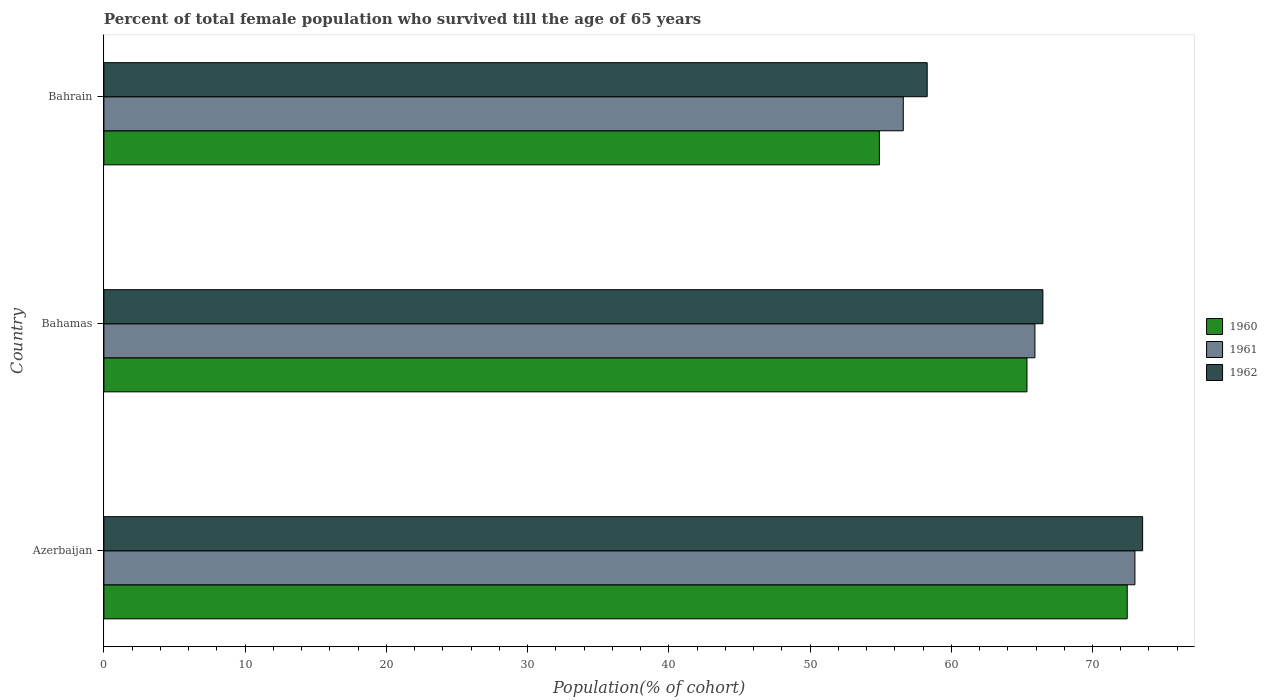How many different coloured bars are there?
Provide a succinct answer. 3. How many groups of bars are there?
Provide a short and direct response. 3. Are the number of bars on each tick of the Y-axis equal?
Give a very brief answer. Yes. How many bars are there on the 3rd tick from the top?
Offer a terse response. 3. What is the label of the 1st group of bars from the top?
Provide a short and direct response. Bahrain. In how many cases, is the number of bars for a given country not equal to the number of legend labels?
Offer a very short reply. 0. What is the percentage of total female population who survived till the age of 65 years in 1960 in Bahamas?
Your answer should be very brief. 65.36. Across all countries, what is the maximum percentage of total female population who survived till the age of 65 years in 1960?
Keep it short and to the point. 72.46. Across all countries, what is the minimum percentage of total female population who survived till the age of 65 years in 1961?
Ensure brevity in your answer.  56.6. In which country was the percentage of total female population who survived till the age of 65 years in 1962 maximum?
Offer a terse response. Azerbaijan. In which country was the percentage of total female population who survived till the age of 65 years in 1962 minimum?
Your answer should be very brief. Bahrain. What is the total percentage of total female population who survived till the age of 65 years in 1960 in the graph?
Provide a short and direct response. 192.73. What is the difference between the percentage of total female population who survived till the age of 65 years in 1960 in Bahamas and that in Bahrain?
Your answer should be compact. 10.45. What is the difference between the percentage of total female population who survived till the age of 65 years in 1962 in Bahrain and the percentage of total female population who survived till the age of 65 years in 1960 in Azerbaijan?
Ensure brevity in your answer.  -14.16. What is the average percentage of total female population who survived till the age of 65 years in 1961 per country?
Keep it short and to the point. 65.18. What is the difference between the percentage of total female population who survived till the age of 65 years in 1960 and percentage of total female population who survived till the age of 65 years in 1961 in Bahrain?
Ensure brevity in your answer.  -1.69. In how many countries, is the percentage of total female population who survived till the age of 65 years in 1961 greater than 34 %?
Keep it short and to the point. 3. What is the ratio of the percentage of total female population who survived till the age of 65 years in 1962 in Azerbaijan to that in Bahamas?
Offer a terse response. 1.11. Is the percentage of total female population who survived till the age of 65 years in 1962 in Bahamas less than that in Bahrain?
Provide a short and direct response. No. What is the difference between the highest and the second highest percentage of total female population who survived till the age of 65 years in 1962?
Ensure brevity in your answer.  7.06. What is the difference between the highest and the lowest percentage of total female population who survived till the age of 65 years in 1962?
Your answer should be very brief. 15.25. Is the sum of the percentage of total female population who survived till the age of 65 years in 1962 in Azerbaijan and Bahamas greater than the maximum percentage of total female population who survived till the age of 65 years in 1960 across all countries?
Offer a very short reply. Yes. What does the 3rd bar from the top in Azerbaijan represents?
Make the answer very short. 1960. How many countries are there in the graph?
Offer a terse response. 3. Are the values on the major ticks of X-axis written in scientific E-notation?
Offer a terse response. No. Does the graph contain any zero values?
Make the answer very short. No. Where does the legend appear in the graph?
Your answer should be very brief. Center right. How many legend labels are there?
Ensure brevity in your answer.  3. How are the legend labels stacked?
Give a very brief answer. Vertical. What is the title of the graph?
Make the answer very short. Percent of total female population who survived till the age of 65 years. What is the label or title of the X-axis?
Your answer should be compact. Population(% of cohort). What is the Population(% of cohort) of 1960 in Azerbaijan?
Give a very brief answer. 72.46. What is the Population(% of cohort) in 1961 in Azerbaijan?
Your answer should be compact. 73. What is the Population(% of cohort) of 1962 in Azerbaijan?
Your answer should be very brief. 73.55. What is the Population(% of cohort) in 1960 in Bahamas?
Your answer should be very brief. 65.36. What is the Population(% of cohort) of 1961 in Bahamas?
Offer a very short reply. 65.92. What is the Population(% of cohort) in 1962 in Bahamas?
Your response must be concise. 66.49. What is the Population(% of cohort) in 1960 in Bahrain?
Make the answer very short. 54.91. What is the Population(% of cohort) of 1961 in Bahrain?
Provide a short and direct response. 56.6. What is the Population(% of cohort) of 1962 in Bahrain?
Offer a very short reply. 58.3. Across all countries, what is the maximum Population(% of cohort) in 1960?
Make the answer very short. 72.46. Across all countries, what is the maximum Population(% of cohort) in 1961?
Provide a short and direct response. 73. Across all countries, what is the maximum Population(% of cohort) of 1962?
Ensure brevity in your answer.  73.55. Across all countries, what is the minimum Population(% of cohort) in 1960?
Your response must be concise. 54.91. Across all countries, what is the minimum Population(% of cohort) in 1961?
Offer a very short reply. 56.6. Across all countries, what is the minimum Population(% of cohort) of 1962?
Your answer should be very brief. 58.3. What is the total Population(% of cohort) in 1960 in the graph?
Offer a terse response. 192.73. What is the total Population(% of cohort) in 1961 in the graph?
Provide a succinct answer. 195.53. What is the total Population(% of cohort) in 1962 in the graph?
Ensure brevity in your answer.  198.33. What is the difference between the Population(% of cohort) in 1960 in Azerbaijan and that in Bahamas?
Offer a very short reply. 7.1. What is the difference between the Population(% of cohort) in 1961 in Azerbaijan and that in Bahamas?
Provide a short and direct response. 7.08. What is the difference between the Population(% of cohort) in 1962 in Azerbaijan and that in Bahamas?
Ensure brevity in your answer.  7.06. What is the difference between the Population(% of cohort) of 1960 in Azerbaijan and that in Bahrain?
Provide a short and direct response. 17.55. What is the difference between the Population(% of cohort) of 1961 in Azerbaijan and that in Bahrain?
Your answer should be very brief. 16.4. What is the difference between the Population(% of cohort) of 1962 in Azerbaijan and that in Bahrain?
Ensure brevity in your answer.  15.25. What is the difference between the Population(% of cohort) of 1960 in Bahamas and that in Bahrain?
Your response must be concise. 10.45. What is the difference between the Population(% of cohort) in 1961 in Bahamas and that in Bahrain?
Offer a very short reply. 9.32. What is the difference between the Population(% of cohort) of 1962 in Bahamas and that in Bahrain?
Give a very brief answer. 8.19. What is the difference between the Population(% of cohort) in 1960 in Azerbaijan and the Population(% of cohort) in 1961 in Bahamas?
Provide a short and direct response. 6.54. What is the difference between the Population(% of cohort) in 1960 in Azerbaijan and the Population(% of cohort) in 1962 in Bahamas?
Provide a succinct answer. 5.97. What is the difference between the Population(% of cohort) in 1961 in Azerbaijan and the Population(% of cohort) in 1962 in Bahamas?
Make the answer very short. 6.52. What is the difference between the Population(% of cohort) in 1960 in Azerbaijan and the Population(% of cohort) in 1961 in Bahrain?
Offer a terse response. 15.86. What is the difference between the Population(% of cohort) of 1960 in Azerbaijan and the Population(% of cohort) of 1962 in Bahrain?
Provide a short and direct response. 14.16. What is the difference between the Population(% of cohort) of 1961 in Azerbaijan and the Population(% of cohort) of 1962 in Bahrain?
Keep it short and to the point. 14.71. What is the difference between the Population(% of cohort) in 1960 in Bahamas and the Population(% of cohort) in 1961 in Bahrain?
Provide a succinct answer. 8.76. What is the difference between the Population(% of cohort) in 1960 in Bahamas and the Population(% of cohort) in 1962 in Bahrain?
Keep it short and to the point. 7.07. What is the difference between the Population(% of cohort) in 1961 in Bahamas and the Population(% of cohort) in 1962 in Bahrain?
Provide a succinct answer. 7.63. What is the average Population(% of cohort) of 1960 per country?
Provide a succinct answer. 64.24. What is the average Population(% of cohort) of 1961 per country?
Give a very brief answer. 65.18. What is the average Population(% of cohort) of 1962 per country?
Your response must be concise. 66.11. What is the difference between the Population(% of cohort) of 1960 and Population(% of cohort) of 1961 in Azerbaijan?
Provide a succinct answer. -0.55. What is the difference between the Population(% of cohort) of 1960 and Population(% of cohort) of 1962 in Azerbaijan?
Offer a terse response. -1.09. What is the difference between the Population(% of cohort) in 1961 and Population(% of cohort) in 1962 in Azerbaijan?
Your answer should be compact. -0.55. What is the difference between the Population(% of cohort) of 1960 and Population(% of cohort) of 1961 in Bahamas?
Offer a terse response. -0.56. What is the difference between the Population(% of cohort) of 1960 and Population(% of cohort) of 1962 in Bahamas?
Give a very brief answer. -1.13. What is the difference between the Population(% of cohort) of 1961 and Population(% of cohort) of 1962 in Bahamas?
Offer a terse response. -0.56. What is the difference between the Population(% of cohort) of 1960 and Population(% of cohort) of 1961 in Bahrain?
Your answer should be very brief. -1.69. What is the difference between the Population(% of cohort) of 1960 and Population(% of cohort) of 1962 in Bahrain?
Your answer should be compact. -3.38. What is the difference between the Population(% of cohort) of 1961 and Population(% of cohort) of 1962 in Bahrain?
Keep it short and to the point. -1.69. What is the ratio of the Population(% of cohort) in 1960 in Azerbaijan to that in Bahamas?
Your answer should be compact. 1.11. What is the ratio of the Population(% of cohort) of 1961 in Azerbaijan to that in Bahamas?
Your answer should be very brief. 1.11. What is the ratio of the Population(% of cohort) in 1962 in Azerbaijan to that in Bahamas?
Give a very brief answer. 1.11. What is the ratio of the Population(% of cohort) of 1960 in Azerbaijan to that in Bahrain?
Your response must be concise. 1.32. What is the ratio of the Population(% of cohort) of 1961 in Azerbaijan to that in Bahrain?
Make the answer very short. 1.29. What is the ratio of the Population(% of cohort) in 1962 in Azerbaijan to that in Bahrain?
Your answer should be very brief. 1.26. What is the ratio of the Population(% of cohort) of 1960 in Bahamas to that in Bahrain?
Provide a succinct answer. 1.19. What is the ratio of the Population(% of cohort) in 1961 in Bahamas to that in Bahrain?
Your answer should be very brief. 1.16. What is the ratio of the Population(% of cohort) of 1962 in Bahamas to that in Bahrain?
Your response must be concise. 1.14. What is the difference between the highest and the second highest Population(% of cohort) of 1960?
Offer a terse response. 7.1. What is the difference between the highest and the second highest Population(% of cohort) in 1961?
Offer a very short reply. 7.08. What is the difference between the highest and the second highest Population(% of cohort) in 1962?
Offer a terse response. 7.06. What is the difference between the highest and the lowest Population(% of cohort) of 1960?
Your response must be concise. 17.55. What is the difference between the highest and the lowest Population(% of cohort) in 1961?
Give a very brief answer. 16.4. What is the difference between the highest and the lowest Population(% of cohort) in 1962?
Keep it short and to the point. 15.25. 